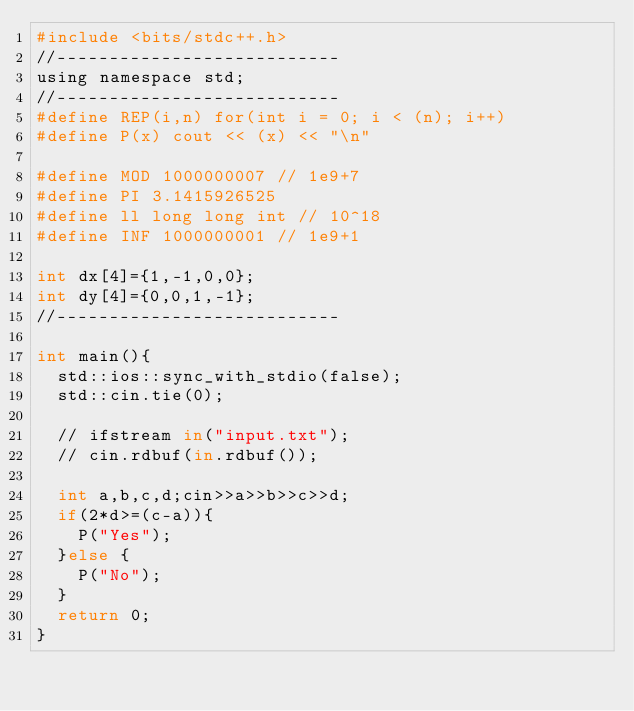Convert code to text. <code><loc_0><loc_0><loc_500><loc_500><_Python_>#include <bits/stdc++.h>
//---------------------------
using namespace std;
//---------------------------
#define REP(i,n) for(int i = 0; i < (n); i++)
#define P(x) cout << (x) << "\n"

#define MOD 1000000007 // 1e9+7
#define PI 3.1415926525
#define ll long long int // 10^18
#define INF 1000000001 // 1e9+1

int dx[4]={1,-1,0,0};
int dy[4]={0,0,1,-1};
//---------------------------

int main(){
  std::ios::sync_with_stdio(false);
  std::cin.tie(0);

  // ifstream in("input.txt");
  // cin.rdbuf(in.rdbuf());

  int a,b,c,d;cin>>a>>b>>c>>d;
  if(2*d>=(c-a)){
    P("Yes");
  }else {
    P("No");
  }
  return 0;
}
</code> 